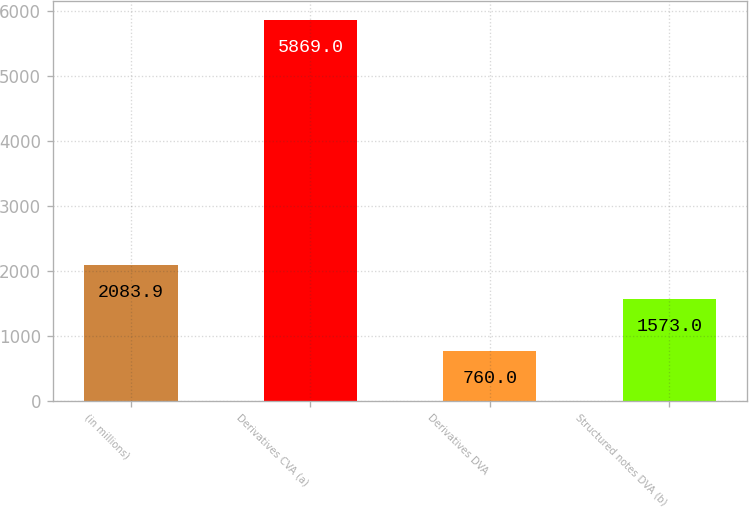<chart> <loc_0><loc_0><loc_500><loc_500><bar_chart><fcel>(in millions)<fcel>Derivatives CVA (a)<fcel>Derivatives DVA<fcel>Structured notes DVA (b)<nl><fcel>2083.9<fcel>5869<fcel>760<fcel>1573<nl></chart> 